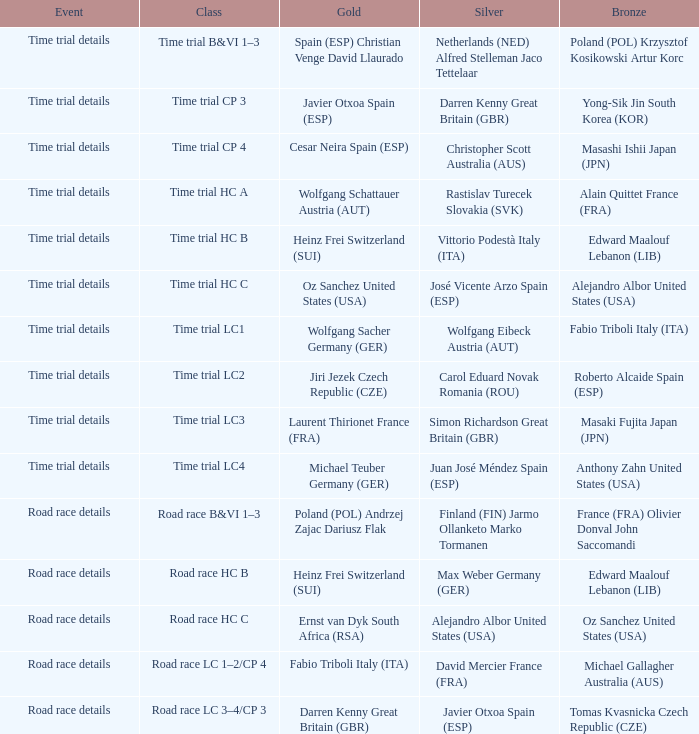Who received gold when the event is time trial details and silver is simon richardson great britain (gbr)? Laurent Thirionet France (FRA). 